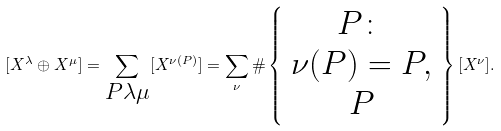Convert formula to latex. <formula><loc_0><loc_0><loc_500><loc_500>[ X ^ { \lambda } \oplus X ^ { \mu } ] = \sum _ { \substack { P \lambda \mu \\ } } [ X ^ { \nu ( P ) } ] = \sum _ { \nu } \# \left \{ \begin{array} { c } P \colon \\ \nu ( P ) = P , \\ P \end{array} \right \} [ X ^ { \nu } ] .</formula> 